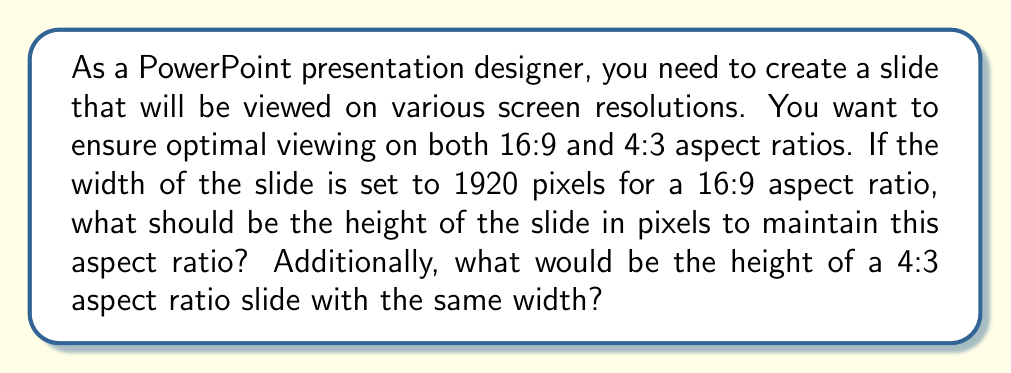What is the answer to this math problem? To solve this problem, we need to understand aspect ratios and how they relate to pixel dimensions.

1. For the 16:9 aspect ratio:
   The aspect ratio is expressed as width:height.
   We can set up the following proportion:
   $$\frac{16}{9} = \frac{1920}{h}$$
   Where h is the unknown height in pixels.

   To solve for h, we cross-multiply:
   $$16h = 9 \cdot 1920$$
   $$16h = 17280$$
   $$h = \frac{17280}{16} = 1080$$

2. For the 4:3 aspect ratio:
   We use the same width (1920 pixels) but a different proportion:
   $$\frac{4}{3} = \frac{1920}{h}$$

   Cross-multiplying again:
   $$4h = 3 \cdot 1920$$
   $$4h = 5760$$
   $$h = \frac{5760}{4} = 1440$$

These calculations ensure that the slide maintains the correct proportions for each aspect ratio while keeping the width constant at 1920 pixels.
Answer: For a 16:9 aspect ratio, the slide dimensions should be 1920x1080 pixels.
For a 4:3 aspect ratio with the same width, the slide dimensions should be 1920x1440 pixels. 